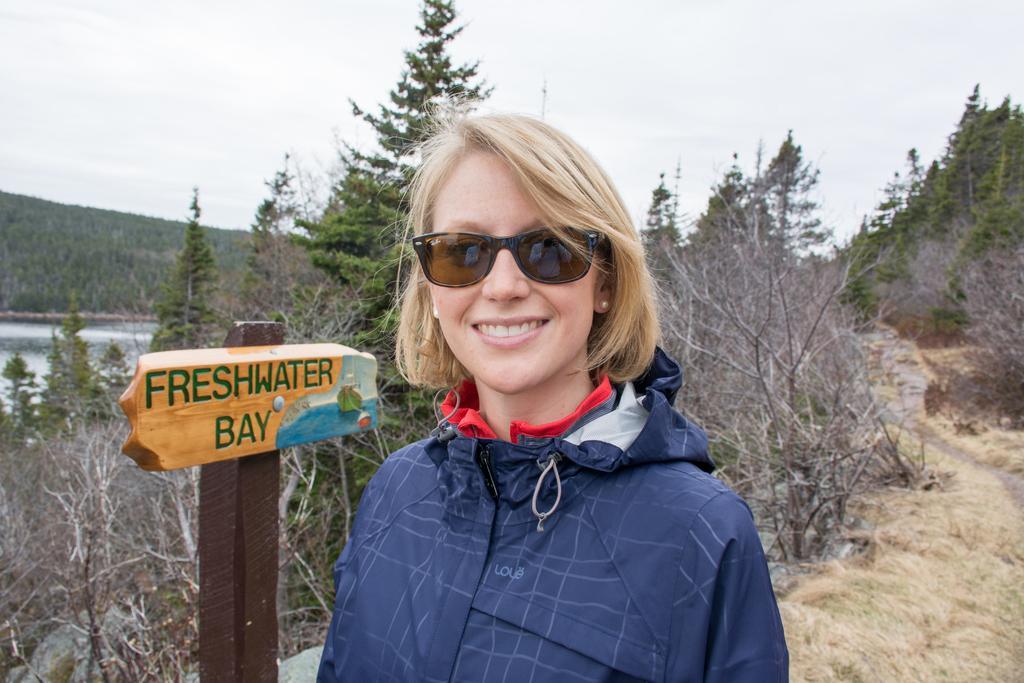In one or two sentences, can you explain what this image depicts? In the picture I can see a woman is standing and smiling. The woman is wearing black color shades and a coat. In the background I can see trees, wooden board which has something written on it, the water and the sky. 